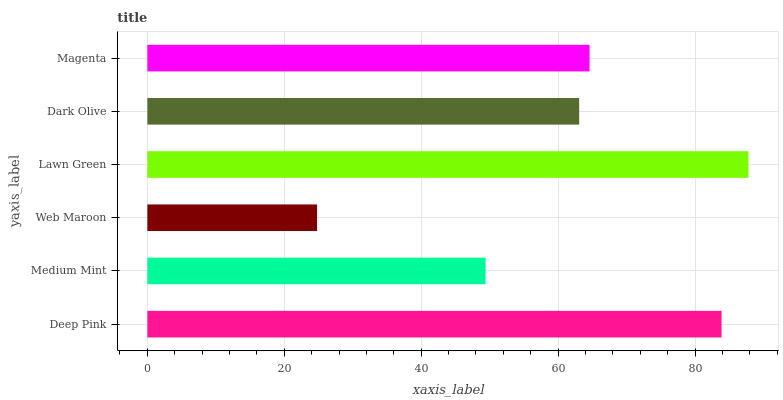Is Web Maroon the minimum?
Answer yes or no. Yes. Is Lawn Green the maximum?
Answer yes or no. Yes. Is Medium Mint the minimum?
Answer yes or no. No. Is Medium Mint the maximum?
Answer yes or no. No. Is Deep Pink greater than Medium Mint?
Answer yes or no. Yes. Is Medium Mint less than Deep Pink?
Answer yes or no. Yes. Is Medium Mint greater than Deep Pink?
Answer yes or no. No. Is Deep Pink less than Medium Mint?
Answer yes or no. No. Is Magenta the high median?
Answer yes or no. Yes. Is Dark Olive the low median?
Answer yes or no. Yes. Is Medium Mint the high median?
Answer yes or no. No. Is Magenta the low median?
Answer yes or no. No. 